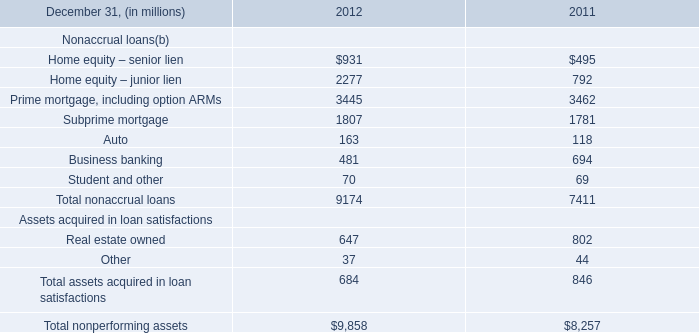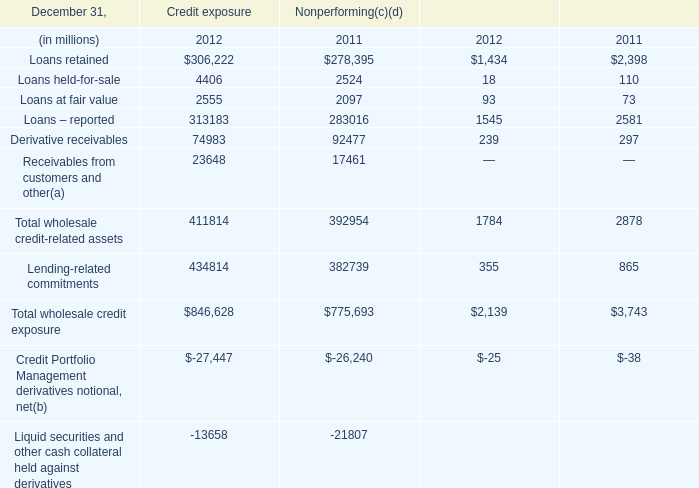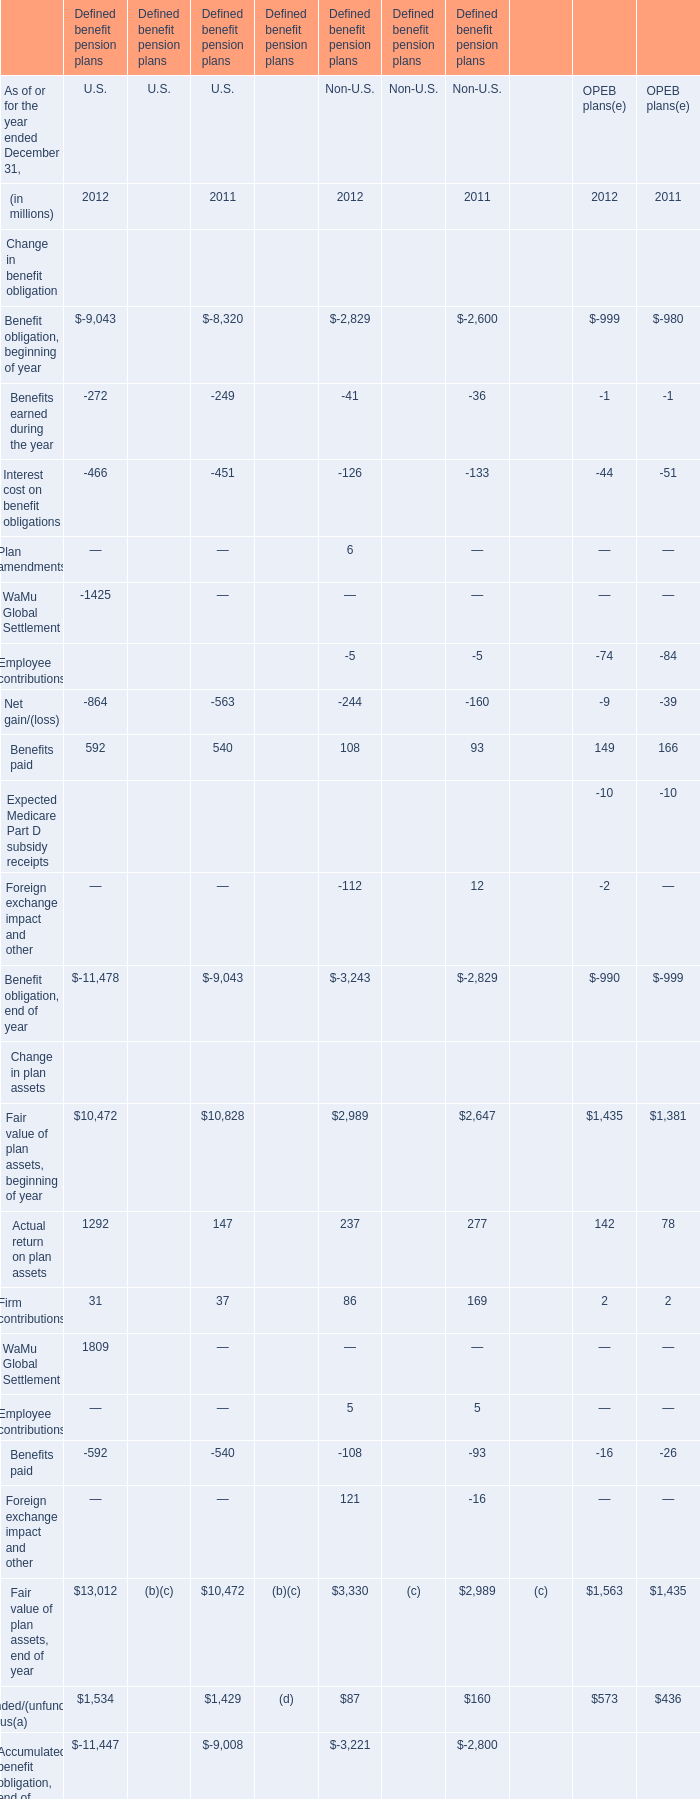What's the current growth rate of Firm contributions for U.S? 
Computations: ((31 - 37) / 37)
Answer: -0.16216. 